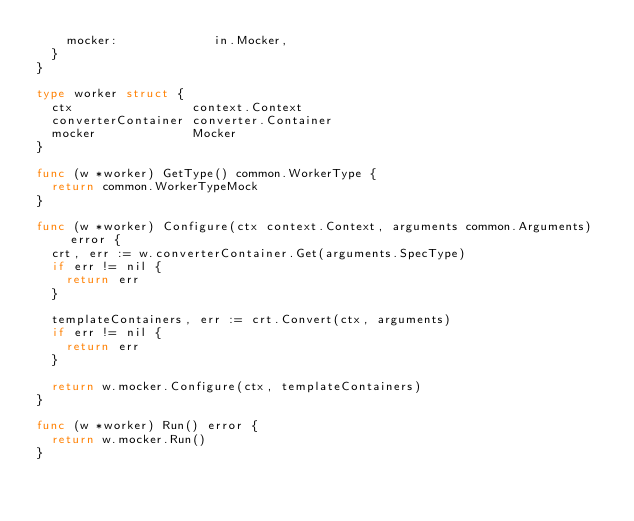Convert code to text. <code><loc_0><loc_0><loc_500><loc_500><_Go_>		mocker:             in.Mocker,
	}
}

type worker struct {
	ctx                context.Context
	converterContainer converter.Container
	mocker             Mocker
}

func (w *worker) GetType() common.WorkerType {
	return common.WorkerTypeMock
}

func (w *worker) Configure(ctx context.Context, arguments common.Arguments) error {
	crt, err := w.converterContainer.Get(arguments.SpecType)
	if err != nil {
		return err
	}

	templateContainers, err := crt.Convert(ctx, arguments)
	if err != nil {
		return err
	}

	return w.mocker.Configure(ctx, templateContainers)
}

func (w *worker) Run() error {
	return w.mocker.Run()
}
</code> 